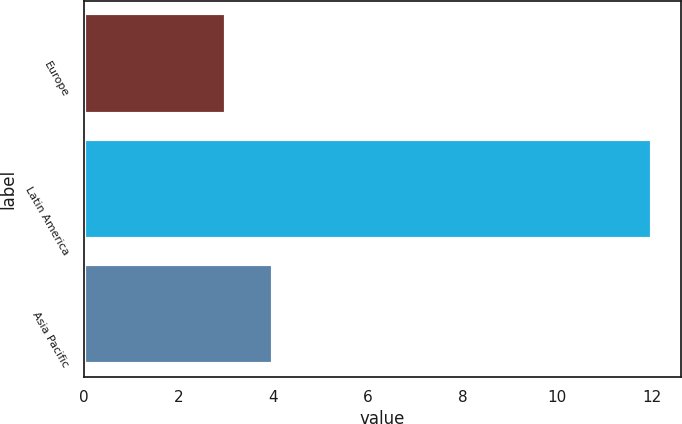<chart> <loc_0><loc_0><loc_500><loc_500><bar_chart><fcel>Europe<fcel>Latin America<fcel>Asia Pacific<nl><fcel>3<fcel>12<fcel>4<nl></chart> 